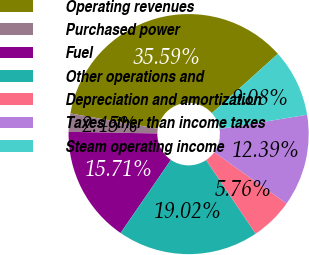Convert chart. <chart><loc_0><loc_0><loc_500><loc_500><pie_chart><fcel>Operating revenues<fcel>Purchased power<fcel>Fuel<fcel>Other operations and<fcel>Depreciation and amortization<fcel>Taxes other than income taxes<fcel>Steam operating income<nl><fcel>35.59%<fcel>2.45%<fcel>15.71%<fcel>19.02%<fcel>5.76%<fcel>12.39%<fcel>9.08%<nl></chart> 